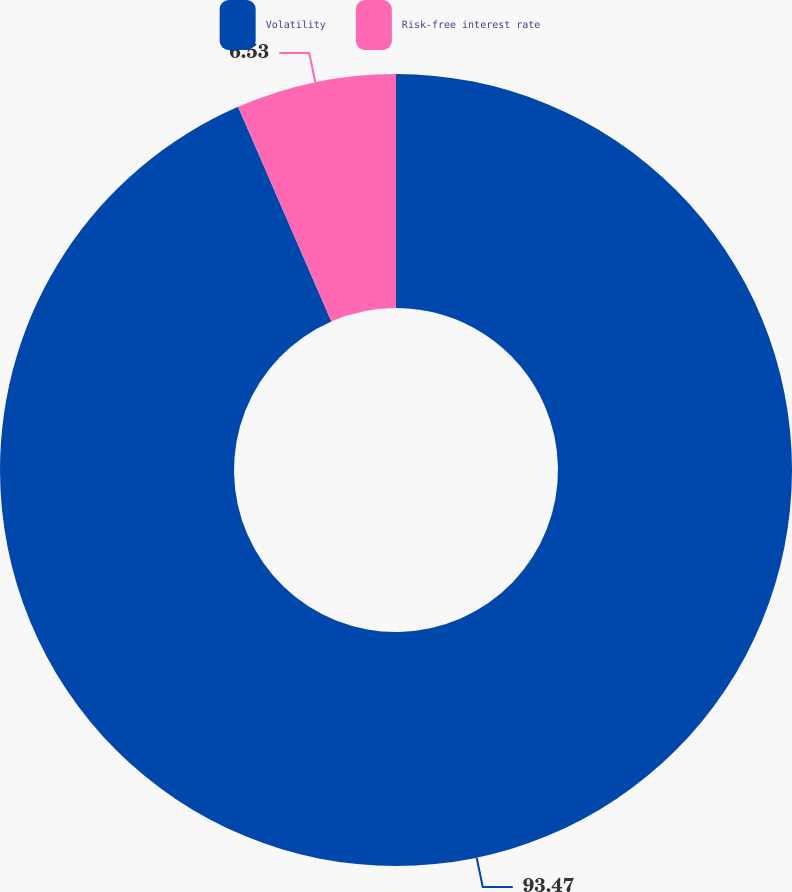<chart> <loc_0><loc_0><loc_500><loc_500><pie_chart><fcel>Volatility<fcel>Risk-free interest rate<nl><fcel>93.47%<fcel>6.53%<nl></chart> 